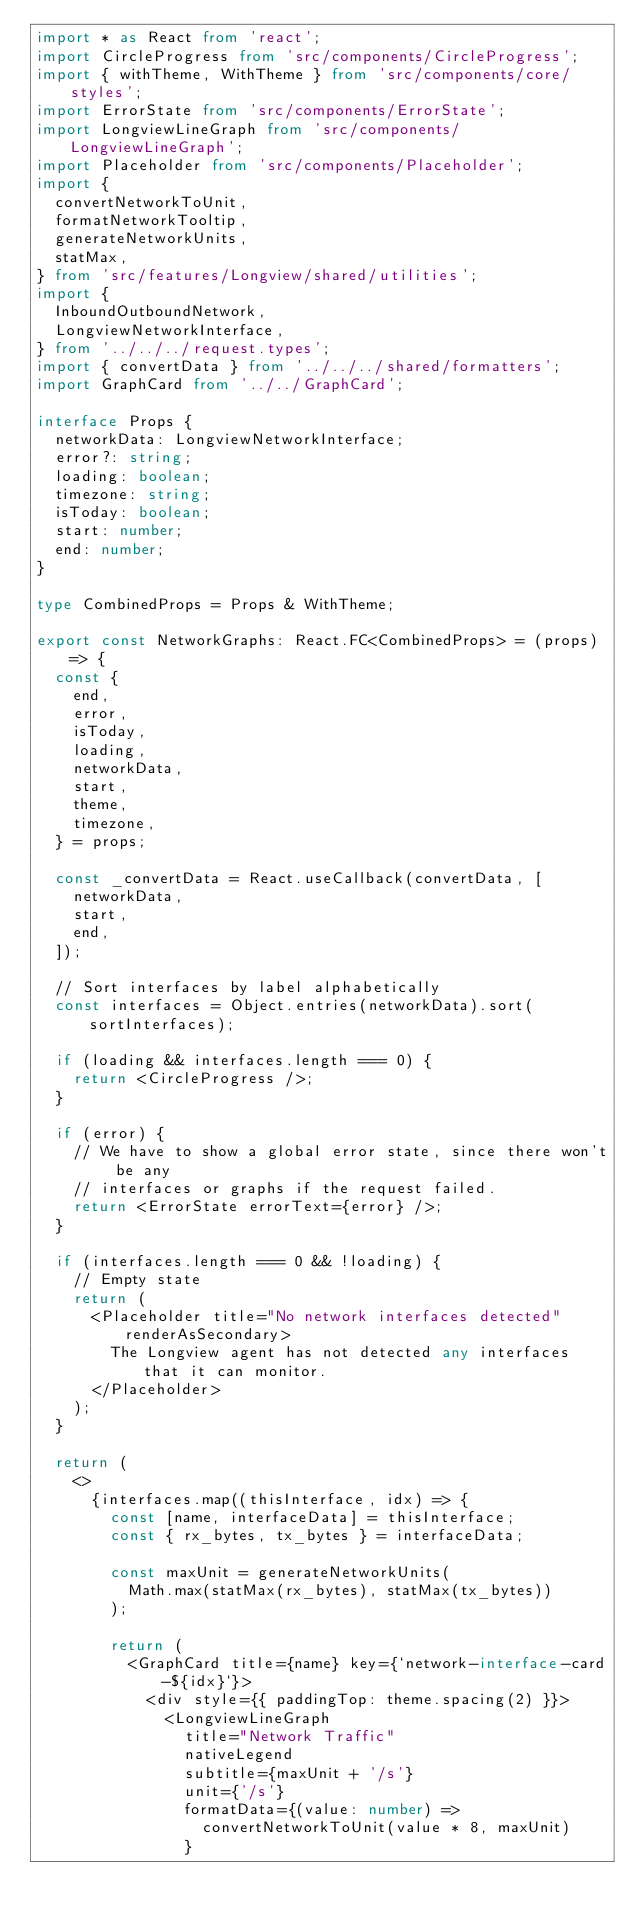Convert code to text. <code><loc_0><loc_0><loc_500><loc_500><_TypeScript_>import * as React from 'react';
import CircleProgress from 'src/components/CircleProgress';
import { withTheme, WithTheme } from 'src/components/core/styles';
import ErrorState from 'src/components/ErrorState';
import LongviewLineGraph from 'src/components/LongviewLineGraph';
import Placeholder from 'src/components/Placeholder';
import {
  convertNetworkToUnit,
  formatNetworkTooltip,
  generateNetworkUnits,
  statMax,
} from 'src/features/Longview/shared/utilities';
import {
  InboundOutboundNetwork,
  LongviewNetworkInterface,
} from '../../../request.types';
import { convertData } from '../../../shared/formatters';
import GraphCard from '../../GraphCard';

interface Props {
  networkData: LongviewNetworkInterface;
  error?: string;
  loading: boolean;
  timezone: string;
  isToday: boolean;
  start: number;
  end: number;
}

type CombinedProps = Props & WithTheme;

export const NetworkGraphs: React.FC<CombinedProps> = (props) => {
  const {
    end,
    error,
    isToday,
    loading,
    networkData,
    start,
    theme,
    timezone,
  } = props;

  const _convertData = React.useCallback(convertData, [
    networkData,
    start,
    end,
  ]);

  // Sort interfaces by label alphabetically
  const interfaces = Object.entries(networkData).sort(sortInterfaces);

  if (loading && interfaces.length === 0) {
    return <CircleProgress />;
  }

  if (error) {
    // We have to show a global error state, since there won't be any
    // interfaces or graphs if the request failed.
    return <ErrorState errorText={error} />;
  }

  if (interfaces.length === 0 && !loading) {
    // Empty state
    return (
      <Placeholder title="No network interfaces detected" renderAsSecondary>
        The Longview agent has not detected any interfaces that it can monitor.
      </Placeholder>
    );
  }

  return (
    <>
      {interfaces.map((thisInterface, idx) => {
        const [name, interfaceData] = thisInterface;
        const { rx_bytes, tx_bytes } = interfaceData;

        const maxUnit = generateNetworkUnits(
          Math.max(statMax(rx_bytes), statMax(tx_bytes))
        );

        return (
          <GraphCard title={name} key={`network-interface-card-${idx}`}>
            <div style={{ paddingTop: theme.spacing(2) }}>
              <LongviewLineGraph
                title="Network Traffic"
                nativeLegend
                subtitle={maxUnit + '/s'}
                unit={'/s'}
                formatData={(value: number) =>
                  convertNetworkToUnit(value * 8, maxUnit)
                }</code> 